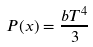Convert formula to latex. <formula><loc_0><loc_0><loc_500><loc_500>P ( x ) = { \frac { b T ^ { 4 } } { 3 } }</formula> 